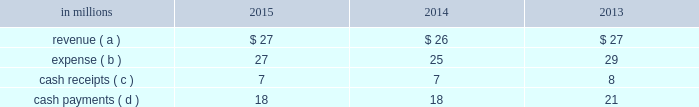( c ) the cash payments are interest payments on the associated debt obligations discussed above .
After formation of the 2015 financing entities , the payments represent interest paid on nonrecourse financial liabilities of special purpose entities .
In connection with the acquisition of temple-inland in february 2012 , two special purpose entities became wholly-owned subsidiaries of international paper .
The use of the two wholly-owned special purpose entities discussed below preserved the tax deferral that resulted from the 2007 temple-inland timberlands sales .
The company recognized an $ 840 million deferred tax liability in connection with the 2007 sales , which will be settled with the maturity of the notes in in october 2007 , temple-inland sold 1.55 million acres of timberland for $ 2.38 billion .
The total consideration consisted almost entirely of notes due in 2027 issued by the buyer of the timberland , which temple-inland contributed to two wholly-owned , bankruptcy-remote special purpose entities .
The notes are shown in financial assets of special purpose entities in the accompanying consolidated balance sheet and are supported by $ 2.38 billion of irrevocable letters of credit issued by three banks , which are required to maintain minimum credit ratings on their long-term debt .
In the third quarter of 2012 , international paper completed its preliminary analysis of the acquisition date fair value of the notes and determined it to be $ 2.09 billion .
As of december 31 , 2015 and 2014 , the fair value of the notes was $ 2.10 billion and $ 2.27 billion , respectively .
These notes are classified as level 2 within the fair value hierarchy , which is further defined in note 14 .
In december 2007 , temple-inland's two wholly-owned special purpose entities borrowed $ 2.14 billion shown in nonrecourse financial liabilities of special purpose entities .
The loans are repayable in 2027 and are secured only by the $ 2.38 billion of notes and the irrevocable letters of credit securing the notes and are nonrecourse to us .
The loan agreements provide that if a credit rating of any of the banks issuing the letters of credit is downgraded below the specified threshold , the letters of credit issued by that bank must be replaced within 30 days with letters of credit from another qualifying financial institution .
In the third quarter of 2012 , international paper completed its preliminary analysis of the acquisition date fair value of the borrowings and determined it to be $ 2.03 billion .
As of december 31 , 2015 and 2014 , the fair value of this debt was $ 1.97 billion and $ 2.16 billion , respectively .
This debt is classified as level 2 within the fair value hierarchy , which is further defined in note 14 .
Activity between the company and the 2007 financing entities was as follows: .
( a ) the revenue is included in interest expense , net in the accompanying consolidated statement of operations and includes approximately $ 19 million , $ 19 million and $ 19 million for the years ended december 31 , 2015 , 2014 and 2013 , respectively , of accretion income for the amortization of the purchase accounting adjustment on the financial assets of special purpose entities .
( b ) the expense is included in interest expense , net in the accompanying consolidated statement of operations and includes approximately $ 7 million , $ 7 million and $ 7 million for the years ended december 31 , 2015 , 2014 and 2013 , respectively , of accretion expense for the amortization of the purchase accounting adjustment on the nonrecourse financial liabilities of special purpose entities .
( c ) the cash receipts are interest received on the financial assets of special purpose entities .
( d ) the cash payments are interest paid on nonrecourse financial liabilities of special purpose entities .
Note 13 debt and lines of credit in 2015 , international paper issued $ 700 million of 3.80% ( 3.80 % ) senior unsecured notes with a maturity date in 2026 , $ 600 million of 5.00% ( 5.00 % ) senior unsecured notes with a maturity date in 2035 , and $ 700 million of 5.15% ( 5.15 % ) senior unsecured notes with a maturity date in 2046 .
The proceeds from this borrowing were used to repay approximately $ 1.0 billion of notes with interest rates ranging from 4.75% ( 4.75 % ) to 9.38% ( 9.38 % ) and original maturities from 2018 to 2022 , along with $ 211 million of cash premiums associated with the debt repayments .
Additionally , the proceeds from this borrowing were used to make a $ 750 million voluntary cash contribution to the company's pension plan .
Pre-tax early debt retirement costs of $ 207 million related to the debt repayments , including the $ 211 million of cash premiums , are included in restructuring and other charges in the accompanying consolidated statement of operations for the twelve months ended december 31 , 2015 .
During the second quarter of 2014 , international paper issued $ 800 million of 3.65% ( 3.65 % ) senior unsecured notes with a maturity date in 2024 and $ 800 million of 4.80% ( 4.80 % ) senior unsecured notes with a maturity date in 2044 .
The proceeds from this borrowing were used to repay approximately $ 960 million of notes with interest rates ranging from 7.95% ( 7.95 % ) to 9.38% ( 9.38 % ) and original maturities from 2018 to 2019 .
Pre-tax early debt retirement costs of $ 262 million related to these debt repayments , including $ 258 million of cash premiums , are included in restructuring and other charges in the accompanying consolidated statement of operations for the twelve months ended december 31 , 2014. .
Based on the activity between the company and the 2007 financing entities what was the ratio of the cash payments to the cash receipts in 2013? 
Computations: (21 / 8)
Answer: 2.625. 